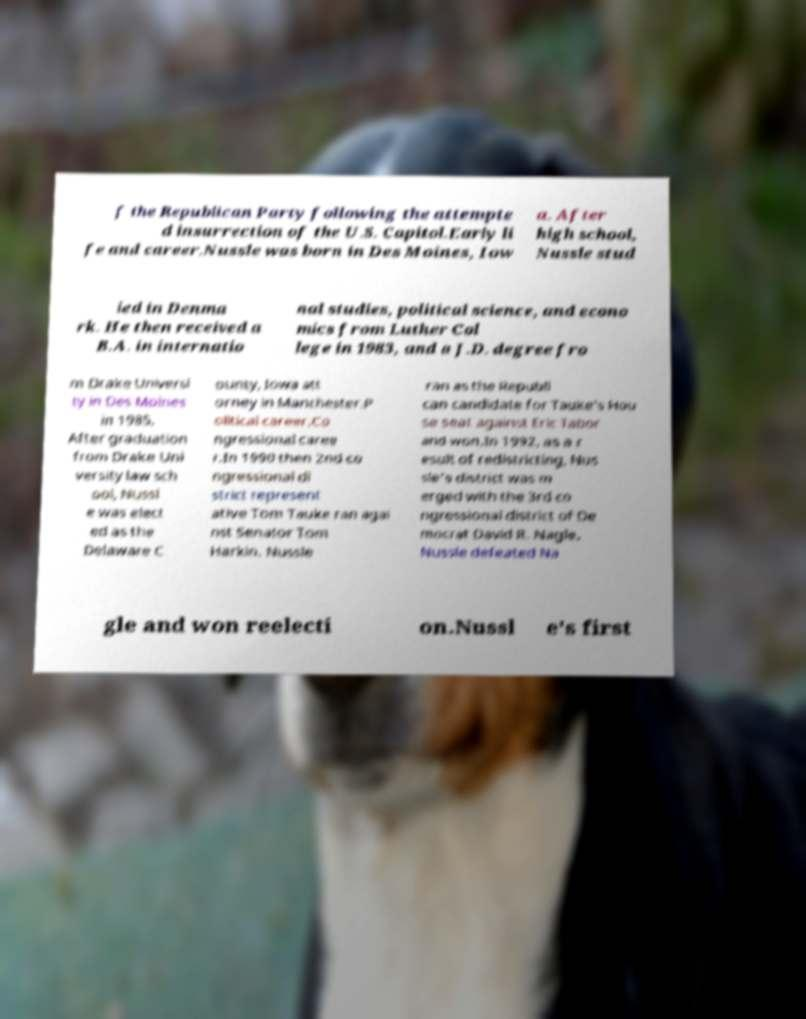Please identify and transcribe the text found in this image. f the Republican Party following the attempte d insurrection of the U.S. Capitol.Early li fe and career.Nussle was born in Des Moines, Iow a. After high school, Nussle stud ied in Denma rk. He then received a B.A. in internatio nal studies, political science, and econo mics from Luther Col lege in 1983, and a J.D. degree fro m Drake Universi ty in Des Moines in 1985. After graduation from Drake Uni versity law sch ool, Nussl e was elect ed as the Delaware C ounty, Iowa att orney in Manchester.P olitical career.Co ngressional caree r.In 1990 then 2nd co ngressional di strict represent ative Tom Tauke ran agai nst Senator Tom Harkin. Nussle ran as the Republi can candidate for Tauke's Hou se seat against Eric Tabor and won.In 1992, as a r esult of redistricting, Nus sle's district was m erged with the 3rd co ngressional district of De mocrat David R. Nagle. Nussle defeated Na gle and won reelecti on.Nussl e's first 